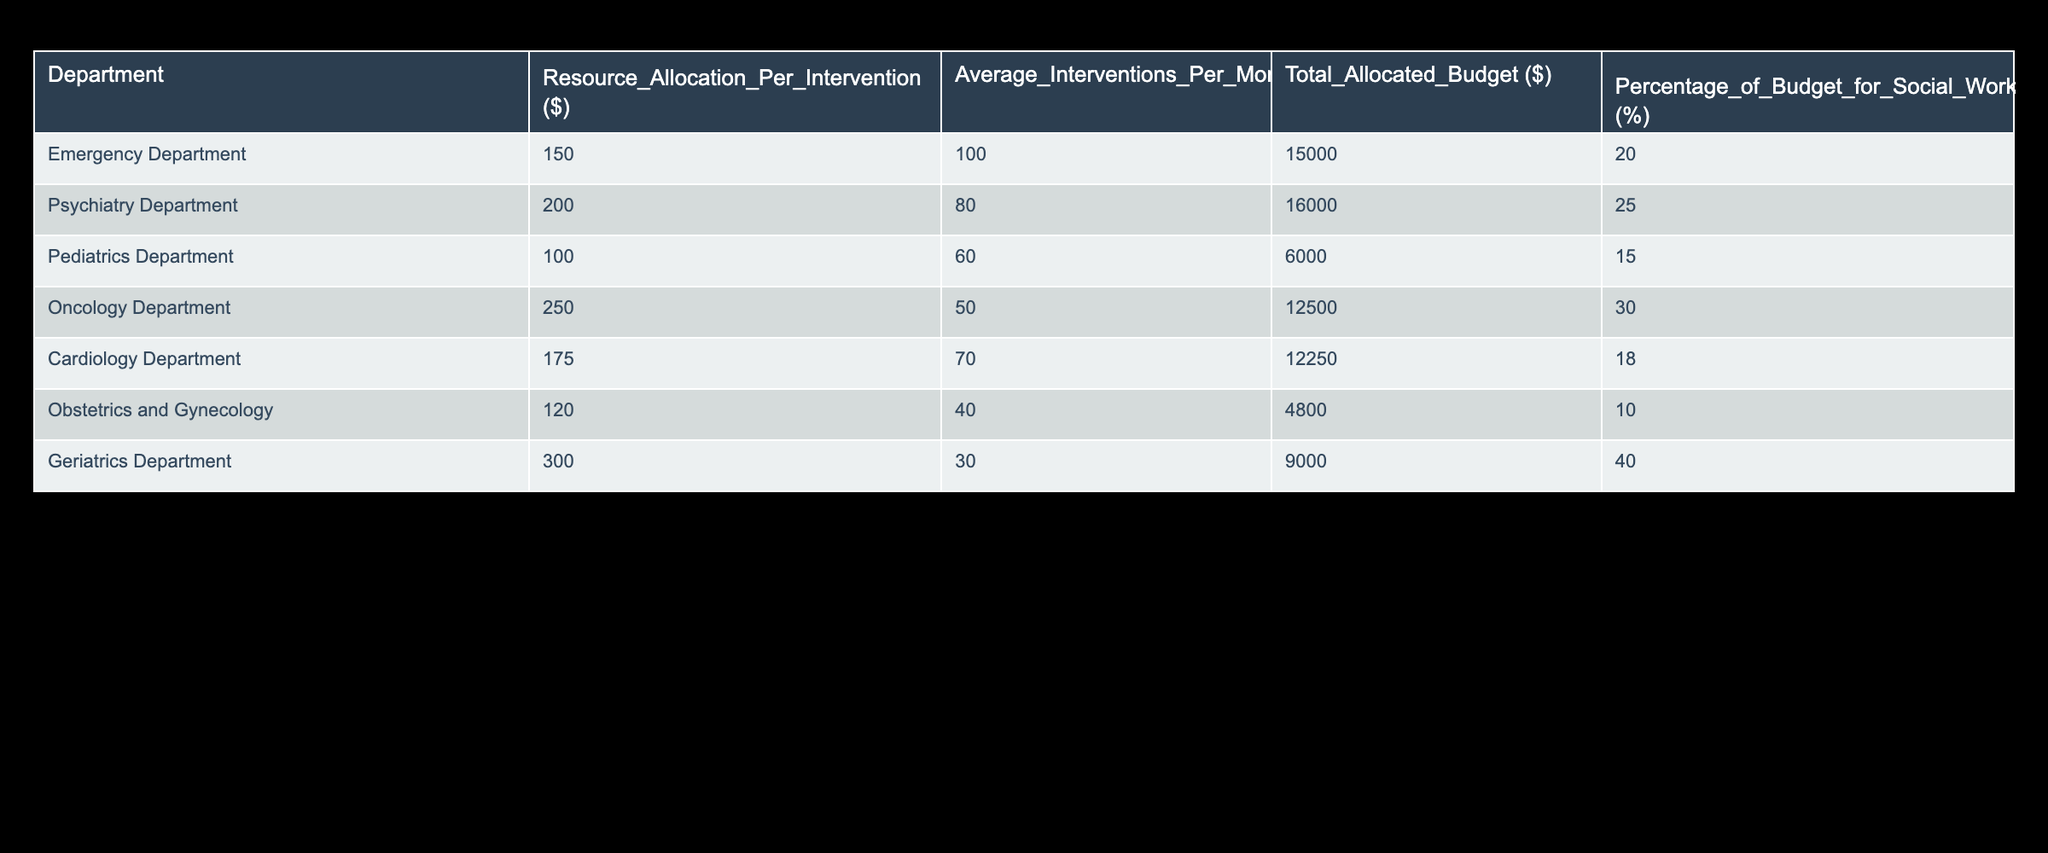What is the total allocated budget for the Emergency Department? From the table, we can see that the "Total Allocated Budget ($)" for the Emergency Department is listed as 15000.
Answer: 15000 Which department has the highest percentage of budget allocated for social work interventions? By checking the "Percentage_of_Budget_for_Social_Work_Interventions (%)" column, we see that the Geriatrics Department has the highest percentage at 40%.
Answer: 40% What is the average resource allocation per intervention for the Pediatrics Department? The table clearly indicates that the "Resource_Allocation_Per_Intervention ($)" for the Pediatrics Department is 100.
Answer: 100 How many average interventions are performed per month in the Oncology Department? Looking at the "Average_Interventions_Per_Month" column, we identify that the Oncology Department performs an average of 50 interventions per month.
Answer: 50 What is the total budget allocated for social work interventions across all departments? To find the total, we sum the "Total Allocated Budget ($)" of all departments: 15000 + 16000 + 6000 + 12500 + 12250 + 4800 + 9000 = 74300.
Answer: 74300 Is the resource allocation per intervention higher in the Psychiatry Department than in the Cardiology Department? The resource allocation for the Psychiatry Department is 200, while for the Cardiology Department, it is 175. Therefore, yes, Psychiatry has a higher allocation.
Answer: Yes What is the difference in total allocated budgets between the Geriatrics Department and the Obstetrics and Gynecology Department? The total budget for Geriatrics Department is 9000 and for Obstetrics and Gynecology is 4800. The difference is 9000 - 4800 = 4200.
Answer: 4200 How many more average interventions does the Emergency Department perform monthly compared to the Geriatrics Department? The Emergency Department performs 100 average interventions per month, whereas the Geriatrics Department performs 30. The difference is 100 - 30 = 70 more interventions.
Answer: 70 Which department has a lower resource allocation per intervention than the Pediatrics Department? The Pediatrics Department has a resource allocation of 100. Departments like Obstetrics and Gynecology (120), Oncology (250), and Cardiology (175) are higher, while no department is lower, as the lowest is the Pediatrics Department itself. Hence, no department is lower.
Answer: No department 